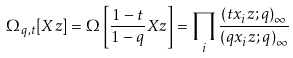<formula> <loc_0><loc_0><loc_500><loc_500>\Omega _ { q , t } [ X z ] = \Omega \left [ \frac { 1 - t } { 1 - q } X z \right ] = \prod _ { i } \frac { ( t x _ { i } z ; q ) _ { \infty } } { ( q x _ { i } z ; q ) _ { \infty } }</formula> 